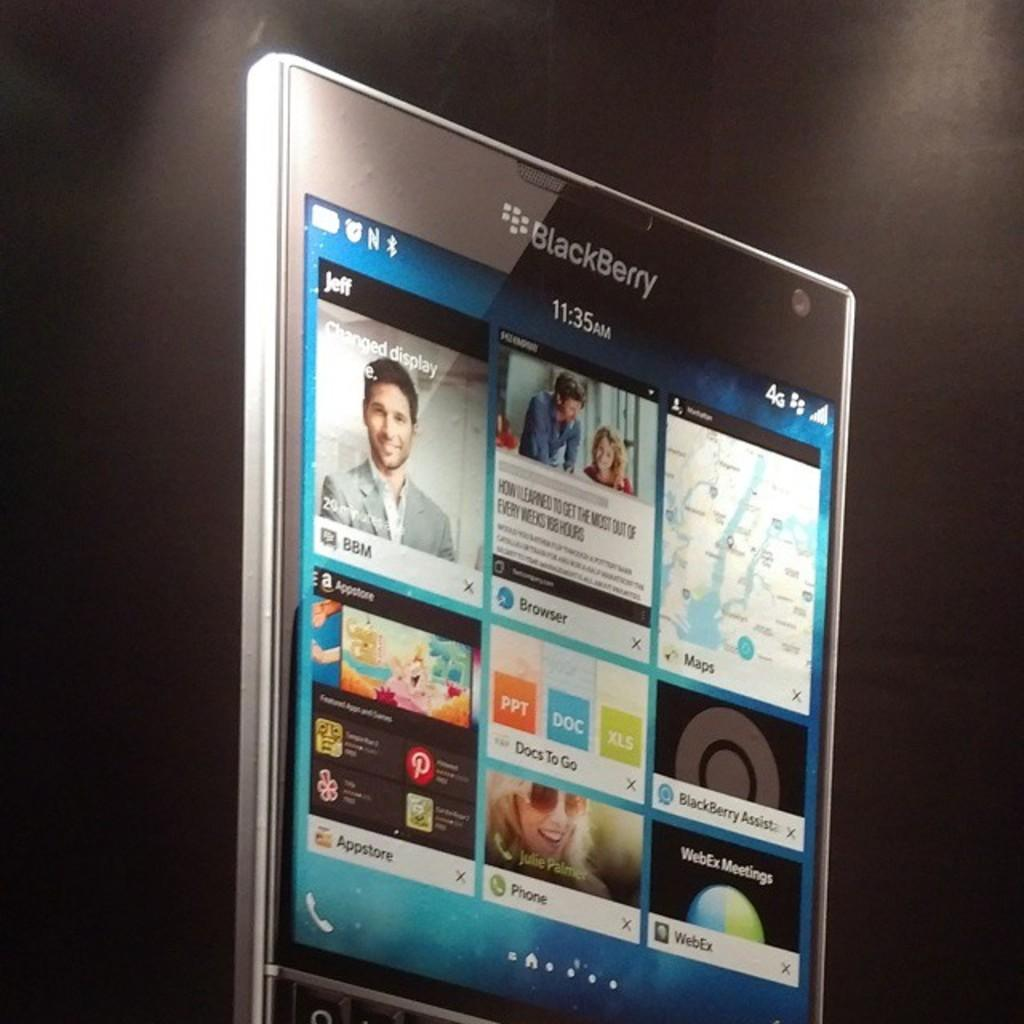<image>
Render a clear and concise summary of the photo. The sleek black mobile device is made by blackberry. 